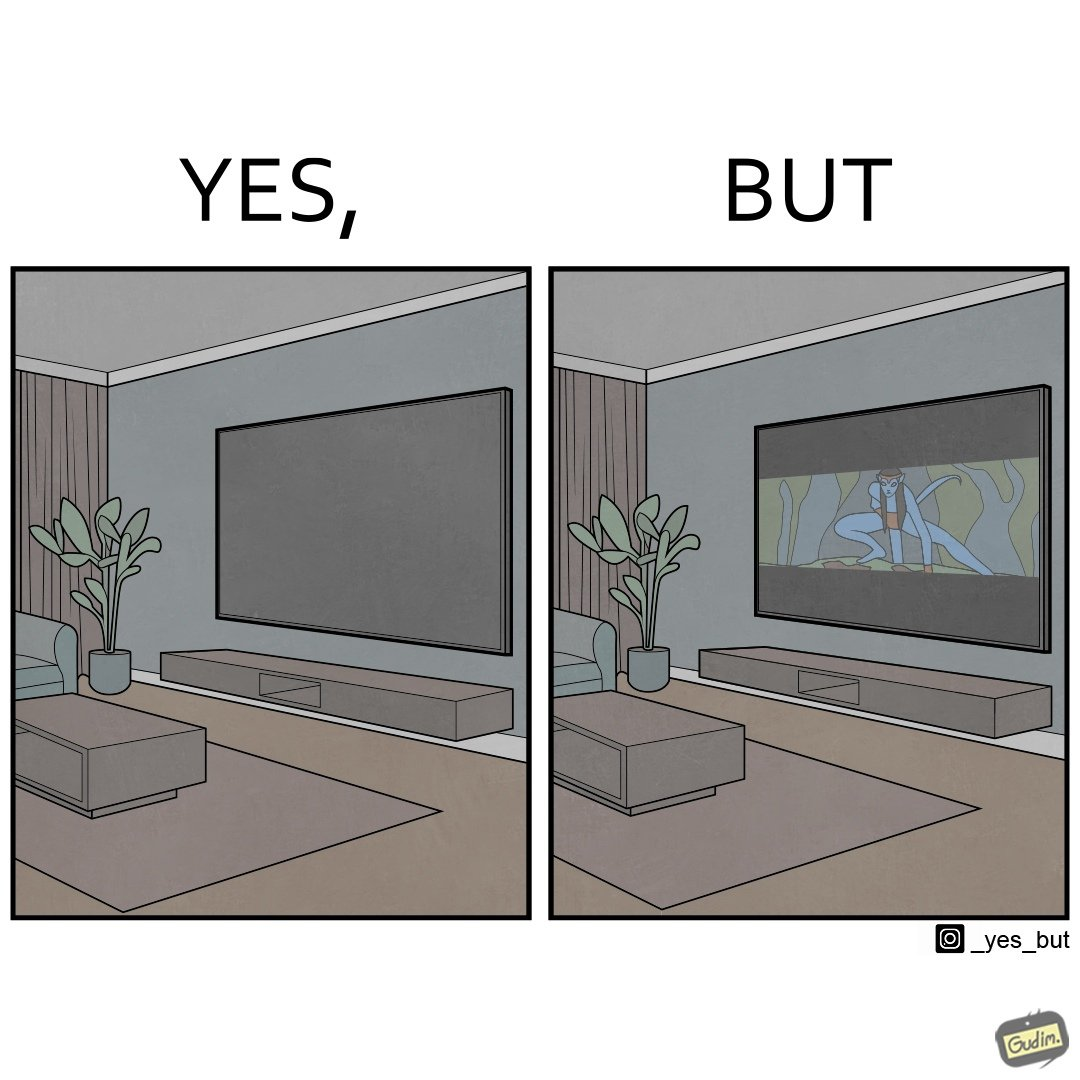Describe the satirical element in this image. The image is funny because while the room has a big TV with a big screen, the movie being played on it does not use the entire screen. 